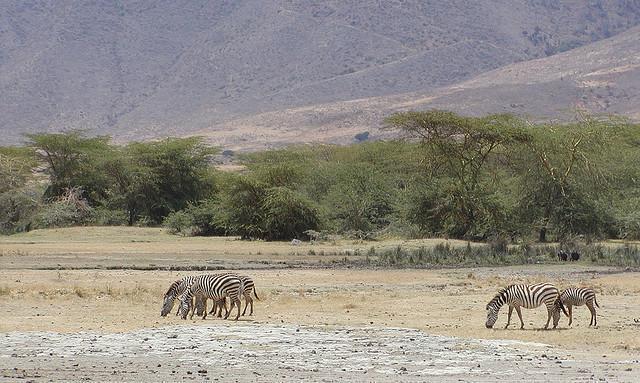What continent do these animals naturally live on?
Choose the correct response, then elucidate: 'Answer: answer
Rationale: rationale.'
Options: Australia, europe, africa, north america. Answer: australia.
Rationale: Zebras are grazing in a dry open landscape. zebras are from africa. 